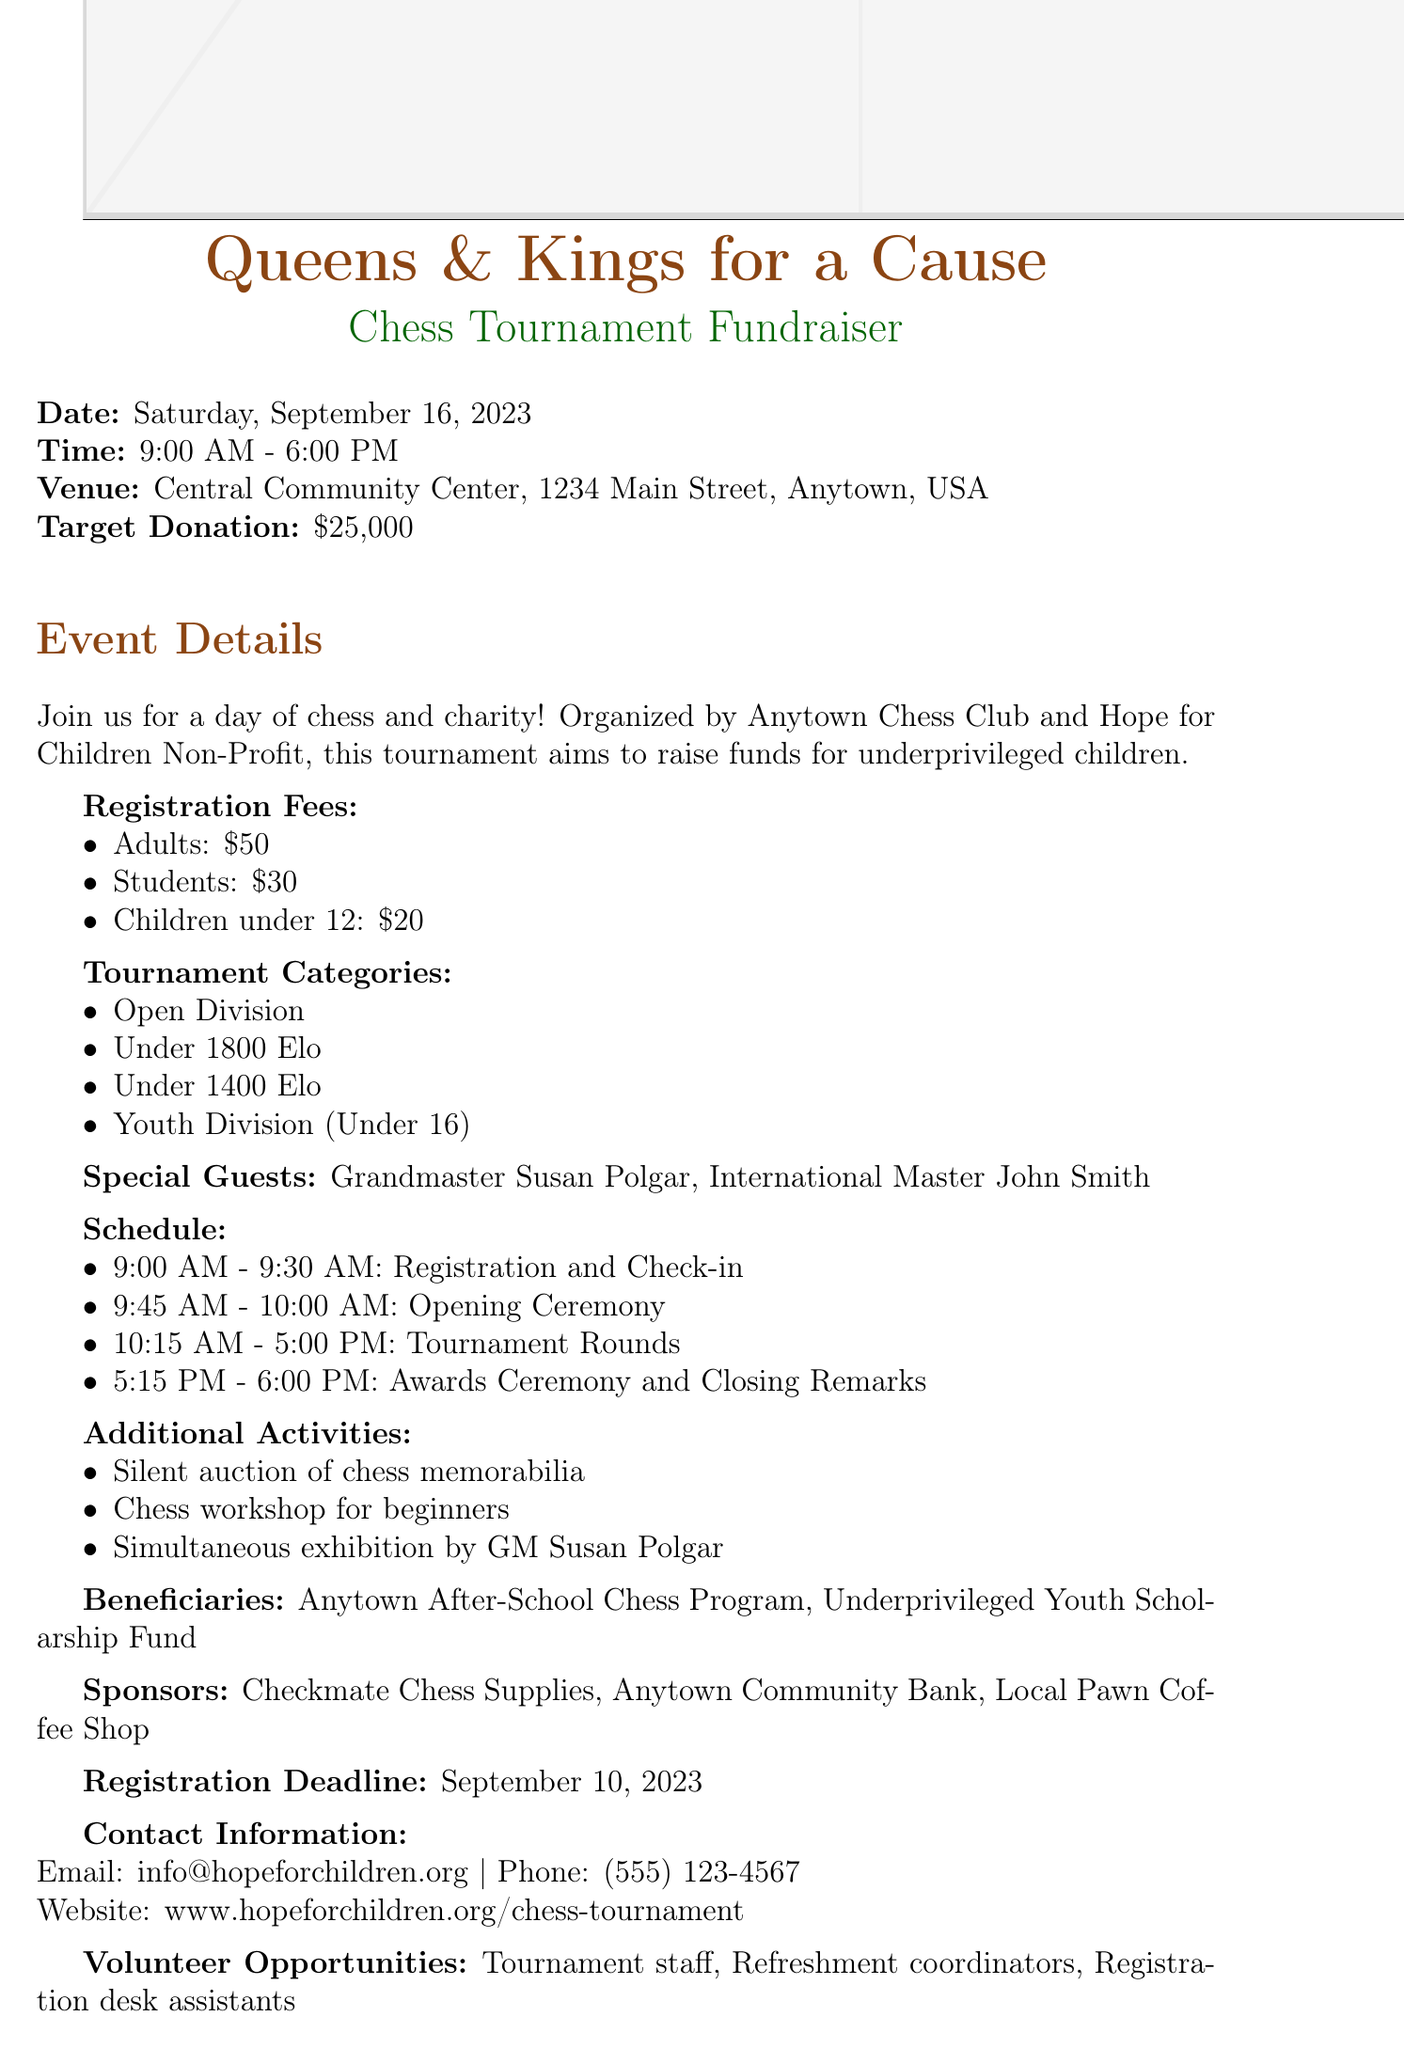What is the name of the chess tournament? The name of the chess tournament is mentioned in the title and is "Queens & Kings for a Cause Chess Tournament".
Answer: Queens & Kings for a Cause Chess Tournament What is the date of the fundraiser? The date is specifically mentioned in the document as "Saturday, September 16, 2023".
Answer: Saturday, September 16, 2023 What is the target donation amount? The target donation amount is clearly stated as "$25,000".
Answer: $25,000 How much is the registration fee for students? The registration fee for students is listed under the registration fees section as "$30".
Answer: $30 Who are the special guests at the tournament? The special guests are explicitly mentioned as "Grandmaster Susan Polgar" and "International Master John Smith".
Answer: Grandmaster Susan Polgar, International Master John Smith What activities are planned apart from the tournament? The document lists additional activities such as a "Silent auction of chess memorabilia", "Chess workshop for beginners", and "Simultaneous exhibition by GM Susan Polgar".
Answer: Silent auction of chess memorabilia, Chess workshop for beginners, Simultaneous exhibition by GM Susan Polgar What time does the tournament start? The starting time for the tournament is indicated in the schedule section as "9:00 AM".
Answer: 9:00 AM What organization is responsible for this tournament along with the chess club? The responsible organization alongside the chess club is stated as "Hope for Children Non-Profit".
Answer: Hope for Children Non-Profit When is the registration deadline? The registration deadline is provided in the document as "September 10, 2023".
Answer: September 10, 2023 